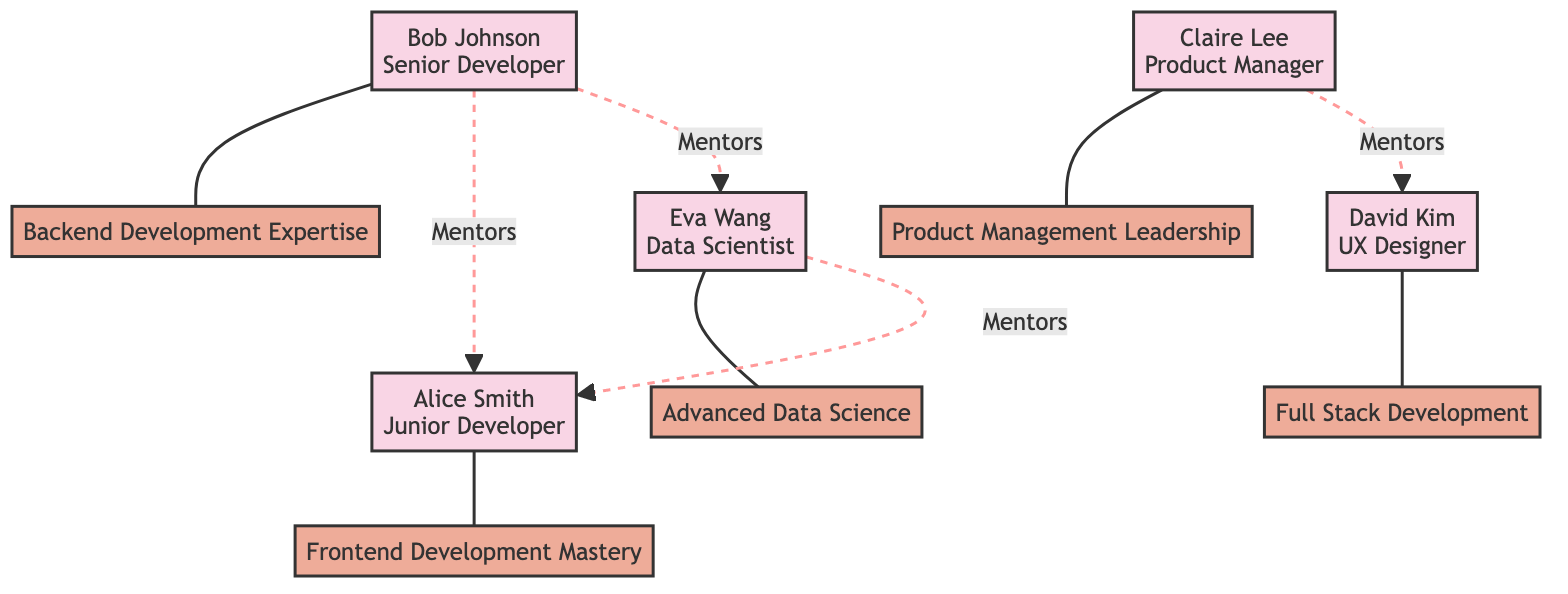What is the role of Alice Smith? According to the diagram, Alice Smith's role is indicated next to her name within the node. It states that she is a Junior Developer.
Answer: Junior Developer How many employees are connected to growth paths? By examining the connections, we can count the number of distinct employee nodes linked to the growth paths. Alice, Bob, Claire, David, and Eva are all connected, making a total of 5 employees.
Answer: 5 Which employee is mentored by Bob Johnson? Looking at the mentorship connections, we can identify that Bob Johnson is linked to Alice Smith and Eva Wang through mentorship lines. Hence, the answer will be Alice Smith and Eva Wang, but one mentor is asked for.
Answer: Alice Smith What is the mentorship connection between Claire Lee and David Kim? The diagram indicates that Claire Lee is a mentor to David Kim. This relationship is represented by a dashed line labeled "Mentors" between these two nodes.
Answer: Mentors How many growth paths are available in the diagram? The growth paths are listed within separate nodes, and by counting them, we find a total of 5 paths: Frontend Development Mastery, Backend Development Expertise, Full Stack Development, Product Management Leadership, and Advanced Data Science.
Answer: 5 Which mentorship connection involves Eva Wang? Examining the dashed connections for Eva Wang shows that she is a mentee to both Alice Smith (mentored by Eva) and is a mentor to Alice Smith, creating a direct mentorship line.
Answer: Alice Smith What is the relationship between David Kim and Claire Lee? The diagram shows that Claire Lee is a mentor to David Kim, which is illustrated through a dashed line labeled "Mentors".
Answer: Mentors How many total mentorship connections are depicted? By counting the dashed connections labeled "Mentors" in the mentorship section, we find there are 4 distinct connections between different employees.
Answer: 4 Which employee is pursuing Frontend Development Mastery? The connection to growth paths shows a direct link from Alice Smith to Frontend Development Mastery, indicating that she is pursuing this growth path.
Answer: Alice Smith 